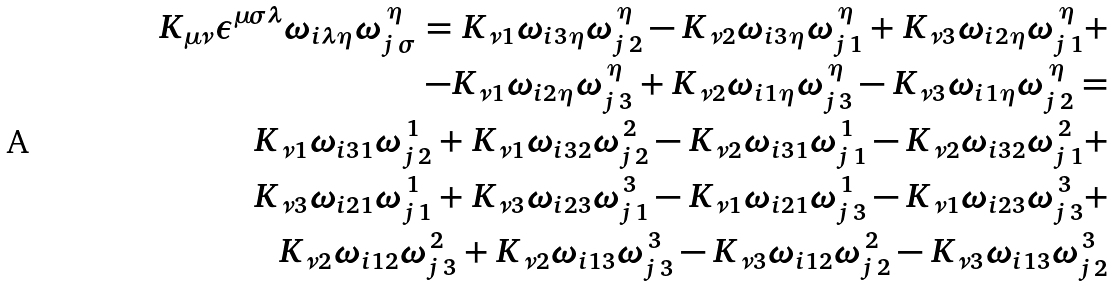Convert formula to latex. <formula><loc_0><loc_0><loc_500><loc_500>K _ { \mu \nu } \epsilon ^ { \mu \sigma \lambda } \omega _ { i \lambda \eta } \omega _ { j \, \sigma } ^ { \, \eta } = K _ { \nu 1 } \omega _ { i 3 \eta } \omega _ { j \, 2 } ^ { \, \eta } - K _ { \nu 2 } \omega _ { i 3 \eta } \omega _ { j \, 1 } ^ { \, \eta } + K _ { \nu 3 } \omega _ { i 2 \eta } \omega _ { j \, 1 } ^ { \, \eta } + \\ - K _ { \nu 1 } \omega _ { i 2 \eta } \omega _ { j \, 3 } ^ { \, \eta } + K _ { \nu 2 } \omega _ { i 1 \eta } \omega _ { j \, 3 } ^ { \, \eta } - K _ { \nu 3 } \omega _ { i 1 \eta } \omega _ { j \, 2 } ^ { \, \eta } = \\ K _ { \nu 1 } \omega _ { i 3 1 } \omega _ { j \, 2 } ^ { \, 1 } + K _ { \nu 1 } \omega _ { i 3 2 } \omega _ { j \, 2 } ^ { \, 2 } - K _ { \nu 2 } \omega _ { i 3 1 } \omega _ { j \, 1 } ^ { \, 1 } - K _ { \nu 2 } \omega _ { i 3 2 } \omega _ { j \, 1 } ^ { \, 2 } + \\ K _ { \nu 3 } \omega _ { i 2 1 } \omega _ { j \, 1 } ^ { \, 1 } + K _ { \nu 3 } \omega _ { i 2 3 } \omega _ { j \, 1 } ^ { \, 3 } - K _ { \nu 1 } \omega _ { i 2 1 } \omega _ { j \, 3 } ^ { \, 1 } - K _ { \nu 1 } \omega _ { i 2 3 } \omega _ { j \, 3 } ^ { \, 3 } + \\ K _ { \nu 2 } \omega _ { i 1 2 } \omega _ { j \, 3 } ^ { \, 2 } + K _ { \nu 2 } \omega _ { i 1 3 } \omega _ { j \, 3 } ^ { \, 3 } - K _ { \nu 3 } \omega _ { i 1 2 } \omega _ { j \, 2 } ^ { \, 2 } - K _ { \nu 3 } \omega _ { i 1 3 } \omega _ { j \, 2 } ^ { \, 3 }</formula> 